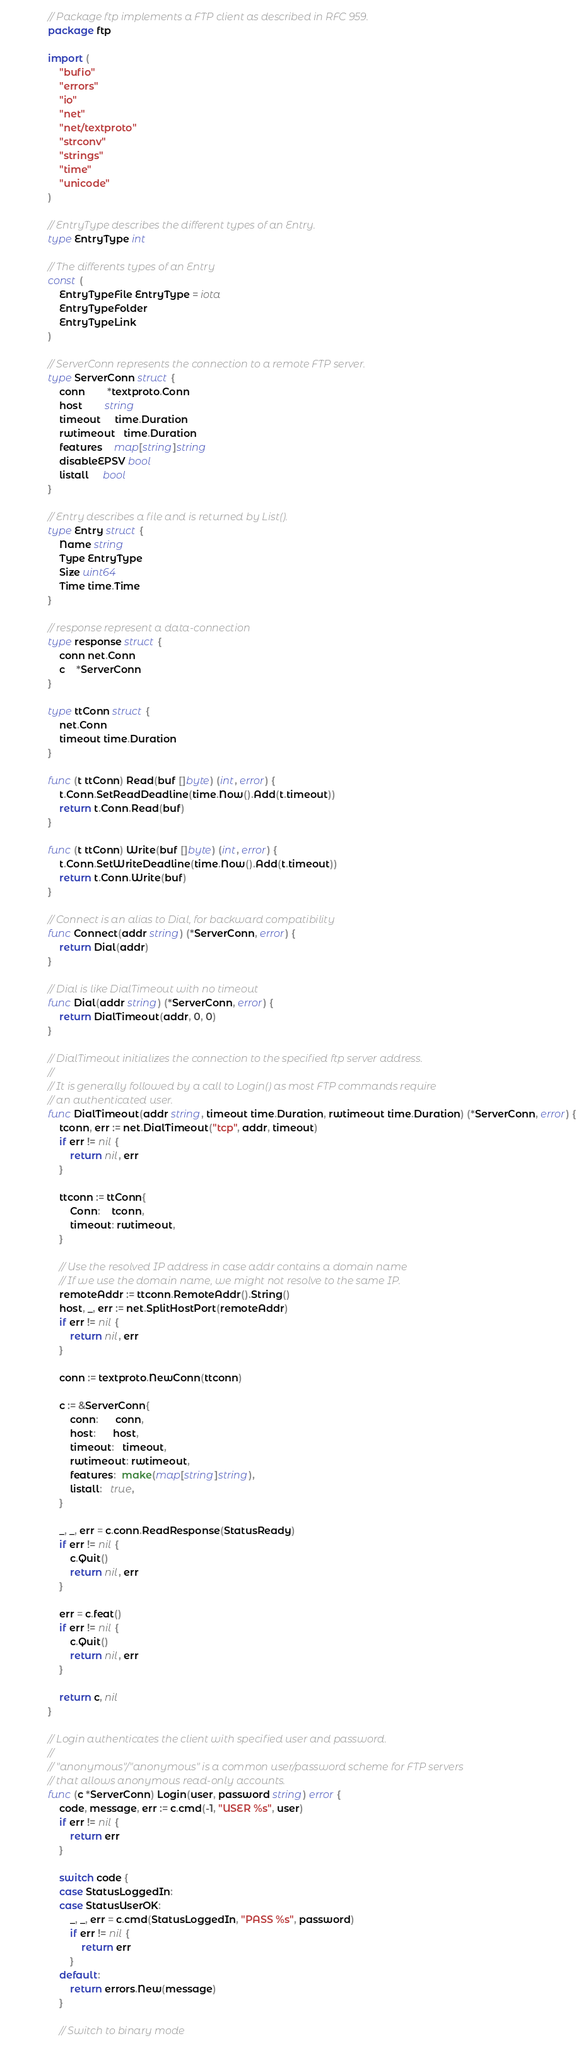<code> <loc_0><loc_0><loc_500><loc_500><_Go_>// Package ftp implements a FTP client as described in RFC 959.
package ftp

import (
	"bufio"
	"errors"
	"io"
	"net"
	"net/textproto"
	"strconv"
	"strings"
	"time"
	"unicode"
)

// EntryType describes the different types of an Entry.
type EntryType int

// The differents types of an Entry
const (
	EntryTypeFile EntryType = iota
	EntryTypeFolder
	EntryTypeLink
)

// ServerConn represents the connection to a remote FTP server.
type ServerConn struct {
	conn        *textproto.Conn
	host        string
	timeout     time.Duration
	rwtimeout   time.Duration
	features    map[string]string
	disableEPSV bool
	listall     bool
}

// Entry describes a file and is returned by List().
type Entry struct {
	Name string
	Type EntryType
	Size uint64
	Time time.Time
}

// response represent a data-connection
type response struct {
	conn net.Conn
	c    *ServerConn
}

type ttConn struct {
	net.Conn
	timeout time.Duration
}

func (t ttConn) Read(buf []byte) (int, error) {
	t.Conn.SetReadDeadline(time.Now().Add(t.timeout))
	return t.Conn.Read(buf)
}

func (t ttConn) Write(buf []byte) (int, error) {
	t.Conn.SetWriteDeadline(time.Now().Add(t.timeout))
	return t.Conn.Write(buf)
}

// Connect is an alias to Dial, for backward compatibility
func Connect(addr string) (*ServerConn, error) {
	return Dial(addr)
}

// Dial is like DialTimeout with no timeout
func Dial(addr string) (*ServerConn, error) {
	return DialTimeout(addr, 0, 0)
}

// DialTimeout initializes the connection to the specified ftp server address.
//
// It is generally followed by a call to Login() as most FTP commands require
// an authenticated user.
func DialTimeout(addr string, timeout time.Duration, rwtimeout time.Duration) (*ServerConn, error) {
	tconn, err := net.DialTimeout("tcp", addr, timeout)
	if err != nil {
		return nil, err
	}

	ttconn := ttConn{
		Conn:    tconn,
		timeout: rwtimeout,
	}

	// Use the resolved IP address in case addr contains a domain name
	// If we use the domain name, we might not resolve to the same IP.
	remoteAddr := ttconn.RemoteAddr().String()
	host, _, err := net.SplitHostPort(remoteAddr)
	if err != nil {
		return nil, err
	}

	conn := textproto.NewConn(ttconn)

	c := &ServerConn{
		conn:      conn,
		host:      host,
		timeout:   timeout,
		rwtimeout: rwtimeout,
		features:  make(map[string]string),
		listall:   true,
	}

	_, _, err = c.conn.ReadResponse(StatusReady)
	if err != nil {
		c.Quit()
		return nil, err
	}

	err = c.feat()
	if err != nil {
		c.Quit()
		return nil, err
	}

	return c, nil
}

// Login authenticates the client with specified user and password.
//
// "anonymous"/"anonymous" is a common user/password scheme for FTP servers
// that allows anonymous read-only accounts.
func (c *ServerConn) Login(user, password string) error {
	code, message, err := c.cmd(-1, "USER %s", user)
	if err != nil {
		return err
	}

	switch code {
	case StatusLoggedIn:
	case StatusUserOK:
		_, _, err = c.cmd(StatusLoggedIn, "PASS %s", password)
		if err != nil {
			return err
		}
	default:
		return errors.New(message)
	}

	// Switch to binary mode</code> 